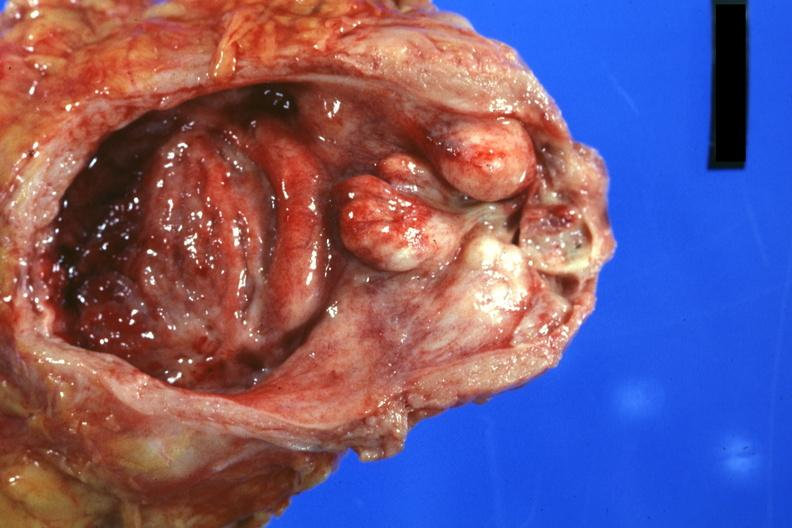s prostate present?
Answer the question using a single word or phrase. Yes 